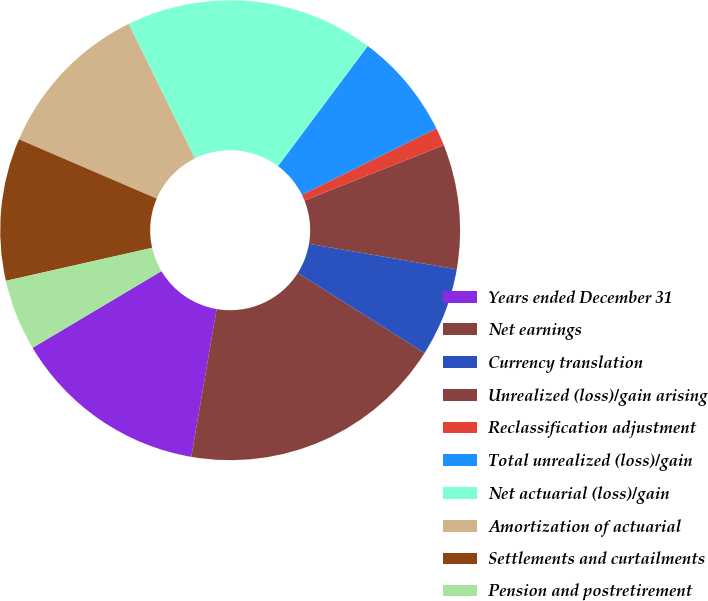Convert chart to OTSL. <chart><loc_0><loc_0><loc_500><loc_500><pie_chart><fcel>Years ended December 31<fcel>Net earnings<fcel>Currency translation<fcel>Unrealized (loss)/gain arising<fcel>Reclassification adjustment<fcel>Total unrealized (loss)/gain<fcel>Net actuarial (loss)/gain<fcel>Amortization of actuarial<fcel>Settlements and curtailments<fcel>Pension and postretirement<nl><fcel>13.75%<fcel>18.74%<fcel>6.25%<fcel>8.75%<fcel>1.26%<fcel>7.5%<fcel>17.49%<fcel>11.25%<fcel>10.0%<fcel>5.01%<nl></chart> 